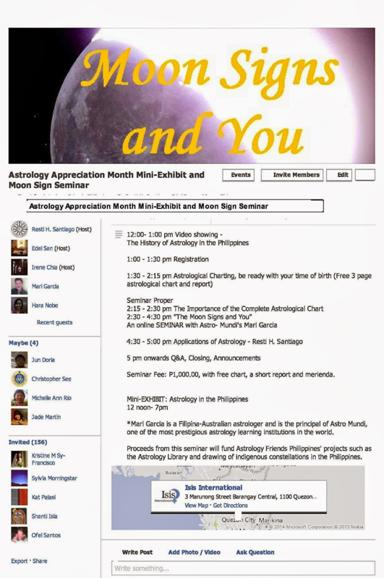What is the seminar fee? The seminar enrollment is priced at P1,000.00. This fee covers a comprehensive bundle including a personal astrological chart, a concise report tailored to you, and a delightful local snack known as merienda, ensuring a fulfilling learning experience. 